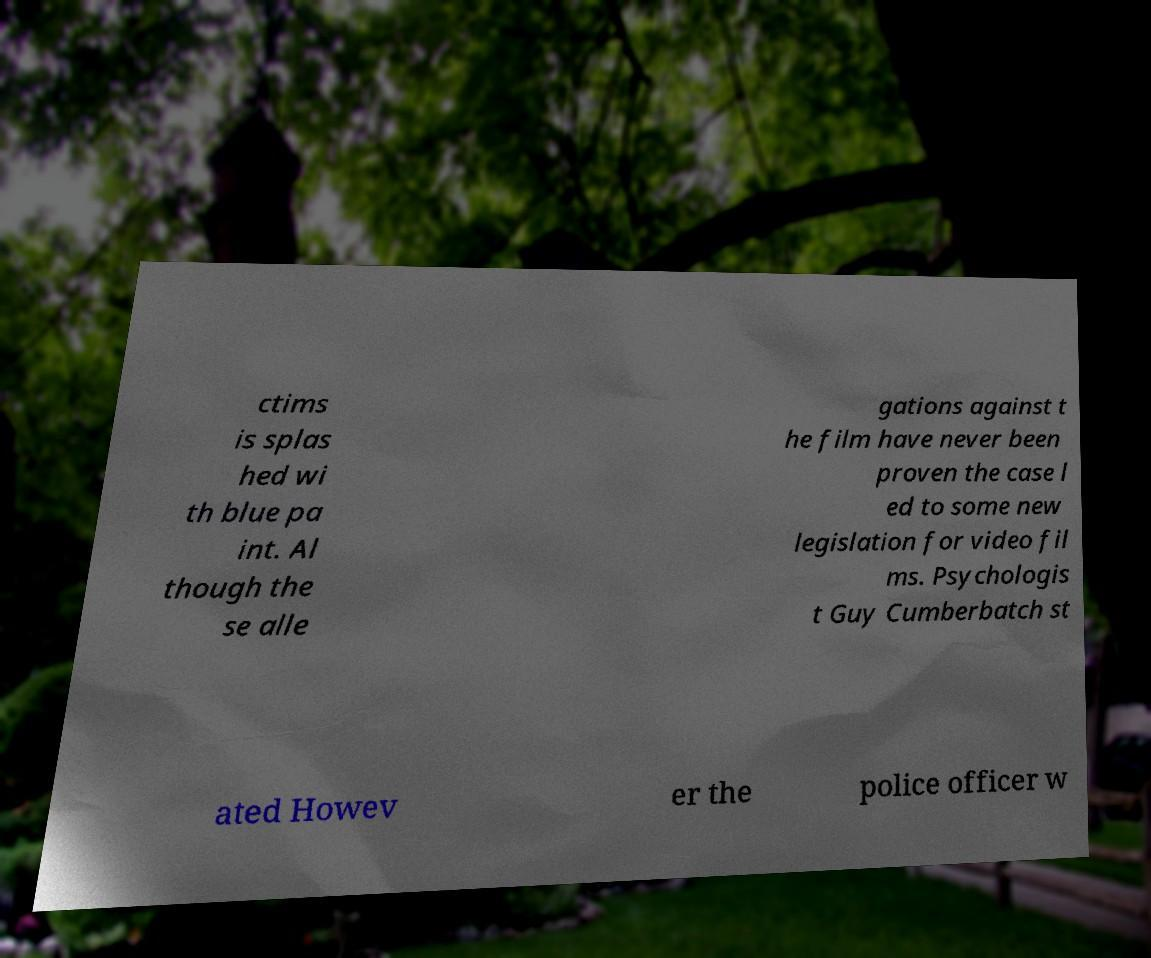What messages or text are displayed in this image? I need them in a readable, typed format. ctims is splas hed wi th blue pa int. Al though the se alle gations against t he film have never been proven the case l ed to some new legislation for video fil ms. Psychologis t Guy Cumberbatch st ated Howev er the police officer w 